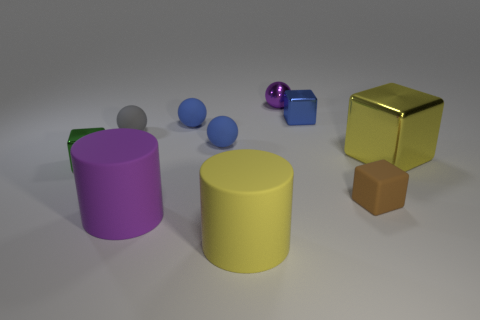What time of day or lighting conditions are suggested by the image? The image suggests an indoor setting that's artificially lit, as evidenced by the soft shadows beneath the objects and the gentle highlights on their surfaces, indicating diffused lighting often used in studio setups. 